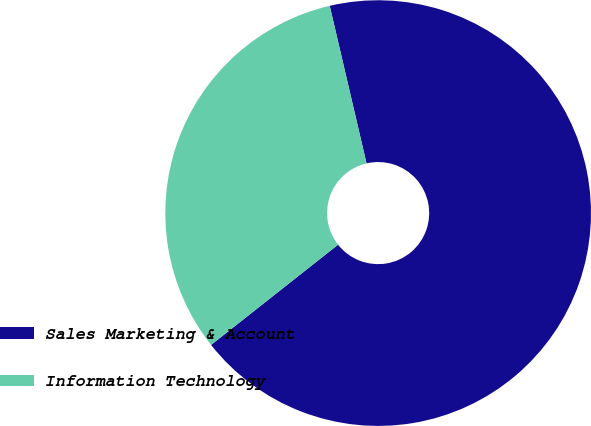Convert chart. <chart><loc_0><loc_0><loc_500><loc_500><pie_chart><fcel>Sales Marketing & Account<fcel>Information Technology<nl><fcel>68.02%<fcel>31.98%<nl></chart> 